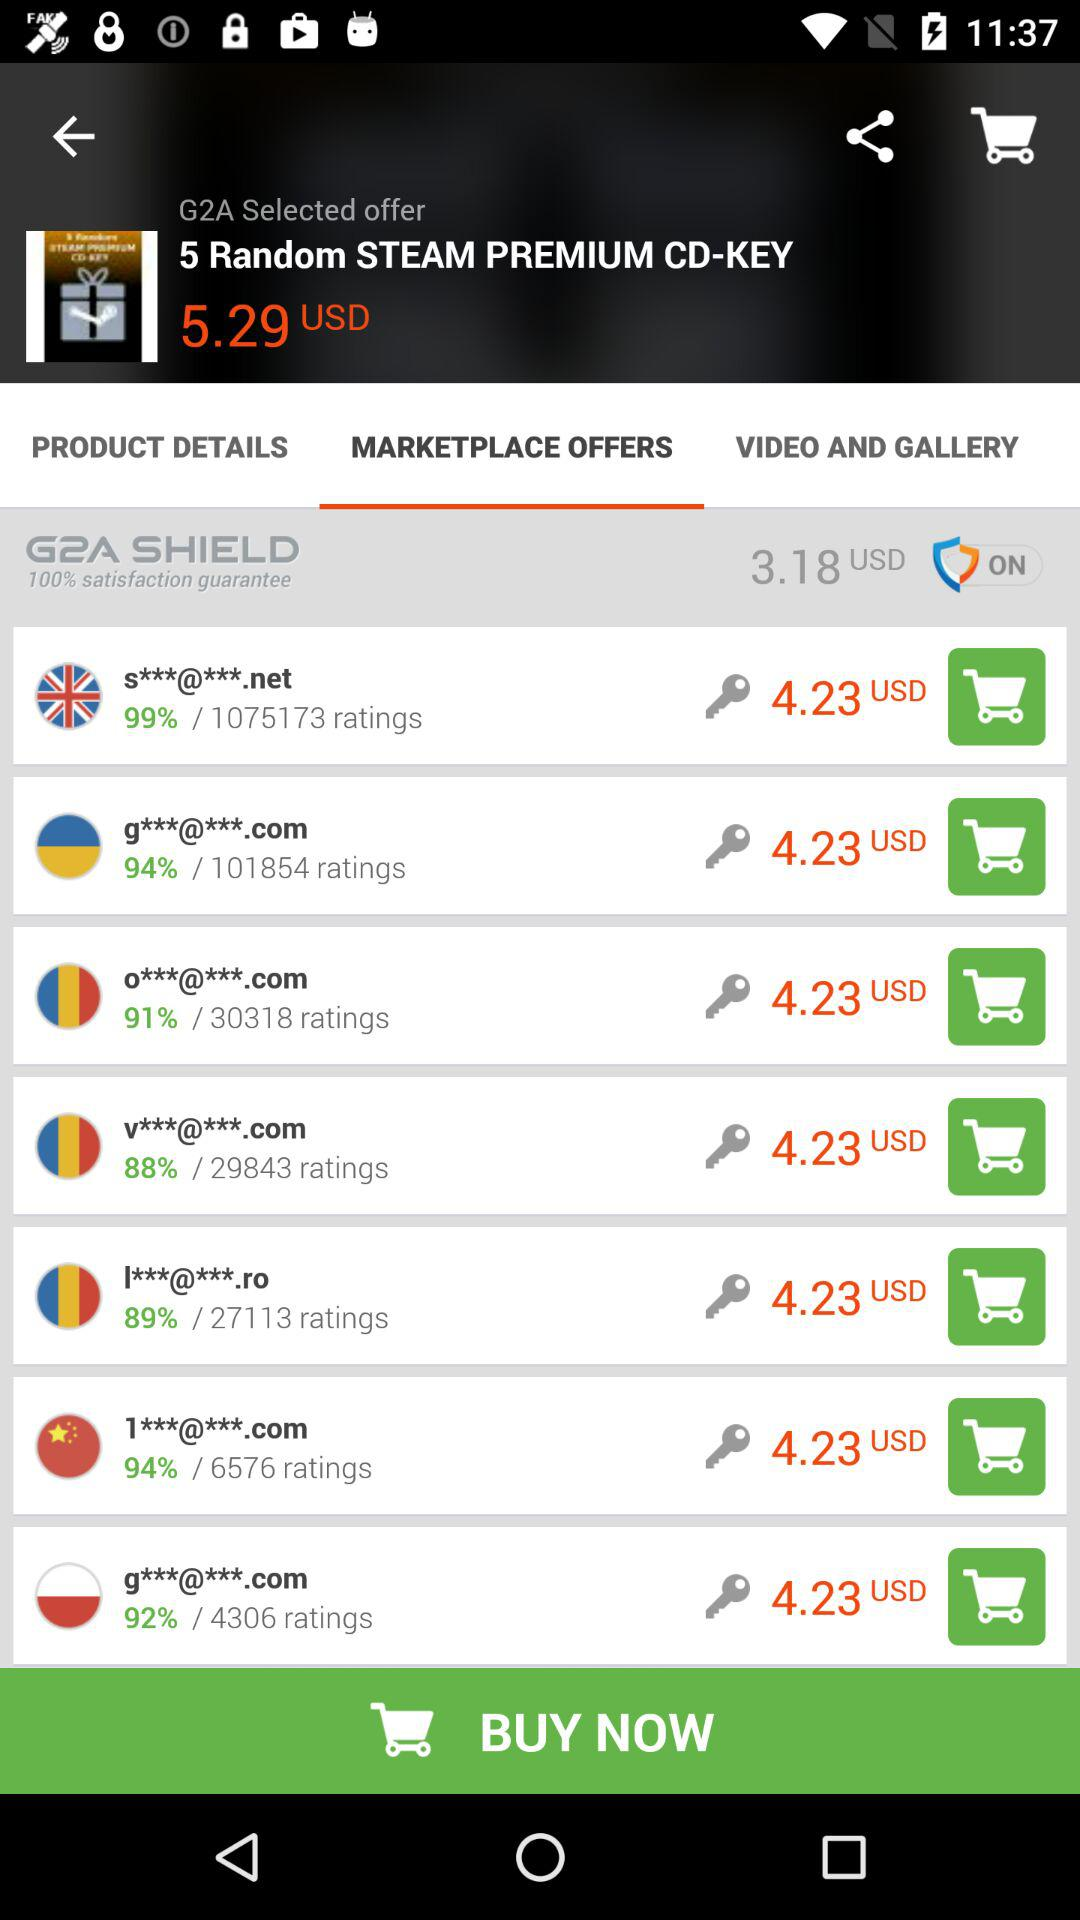Is "G2A SHIELD" on or off? "G2A SHIELD" is on. 